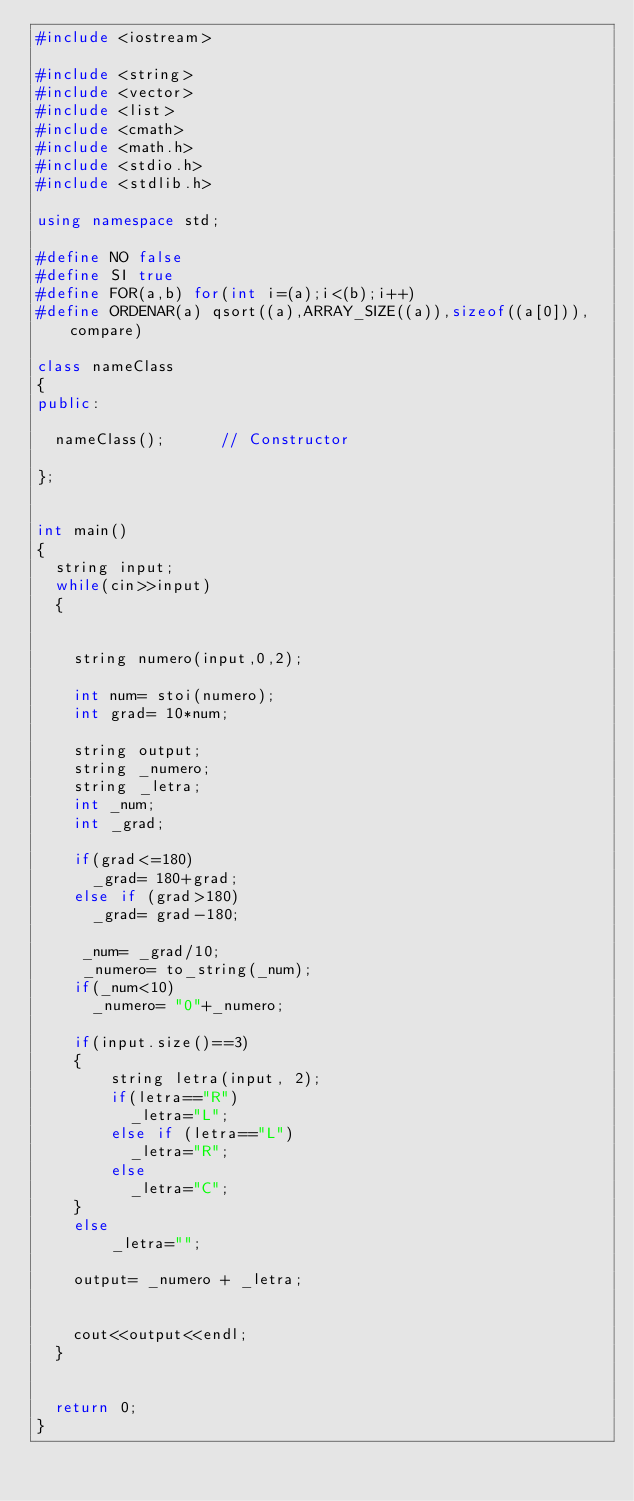Convert code to text. <code><loc_0><loc_0><loc_500><loc_500><_C++_>#include <iostream>

#include <string>
#include <vector>
#include <list>
#include <cmath>
#include <math.h>
#include <stdio.h>
#include <stdlib.h>

using namespace std;

#define NO false
#define SI true
#define FOR(a,b) for(int i=(a);i<(b);i++)
#define ORDENAR(a) qsort((a),ARRAY_SIZE((a)),sizeof((a[0])),compare)

class nameClass
{
public:

  nameClass();      // Constructor

};


int main()
{
  string input;
  while(cin>>input)
  {


    string numero(input,0,2);

    int num= stoi(numero);
    int grad= 10*num;

    string output;
    string _numero;
    string _letra;
    int _num;
    int _grad;

    if(grad<=180)
      _grad= 180+grad;
    else if (grad>180)
      _grad= grad-180;

     _num= _grad/10;
     _numero= to_string(_num);
    if(_num<10)
      _numero= "0"+_numero;

    if(input.size()==3)
    {
        string letra(input, 2);
        if(letra=="R")
          _letra="L";
        else if (letra=="L")
          _letra="R";
        else
          _letra="C";
    }
    else
        _letra="";

    output= _numero + _letra;


    cout<<output<<endl;
  }


  return 0;
}
</code> 